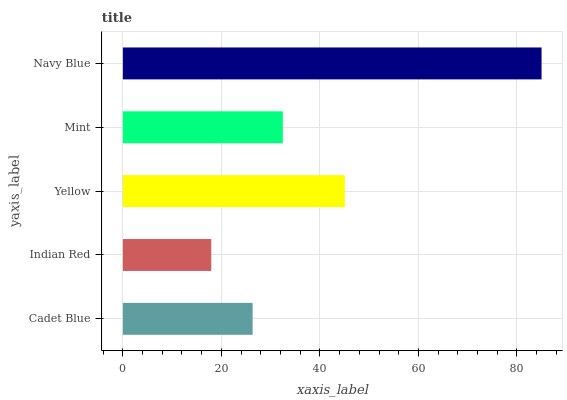Is Indian Red the minimum?
Answer yes or no. Yes. Is Navy Blue the maximum?
Answer yes or no. Yes. Is Yellow the minimum?
Answer yes or no. No. Is Yellow the maximum?
Answer yes or no. No. Is Yellow greater than Indian Red?
Answer yes or no. Yes. Is Indian Red less than Yellow?
Answer yes or no. Yes. Is Indian Red greater than Yellow?
Answer yes or no. No. Is Yellow less than Indian Red?
Answer yes or no. No. Is Mint the high median?
Answer yes or no. Yes. Is Mint the low median?
Answer yes or no. Yes. Is Cadet Blue the high median?
Answer yes or no. No. Is Cadet Blue the low median?
Answer yes or no. No. 